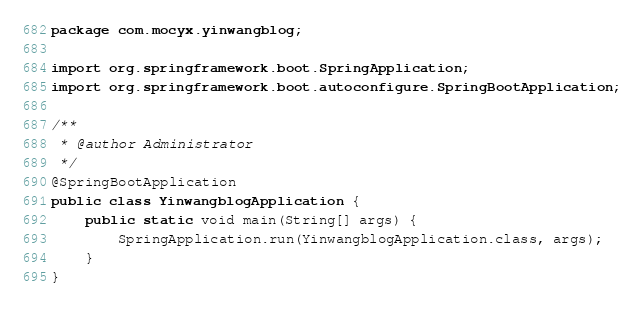<code> <loc_0><loc_0><loc_500><loc_500><_Java_>package com.mocyx.yinwangblog;

import org.springframework.boot.SpringApplication;
import org.springframework.boot.autoconfigure.SpringBootApplication;

/**
 * @author Administrator
 */
@SpringBootApplication
public class YinwangblogApplication {
    public static void main(String[] args) {
        SpringApplication.run(YinwangblogApplication.class, args);
    }
}



</code> 